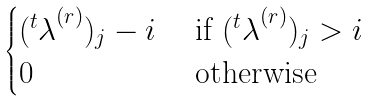<formula> <loc_0><loc_0><loc_500><loc_500>\begin{cases} ( { ^ { t } \lambda } ^ { ( r ) } ) _ { j } - i & \text { if } ( { ^ { t } \lambda } ^ { ( r ) } ) _ { j } > i \\ 0 & \text { otherwise} \end{cases}</formula> 